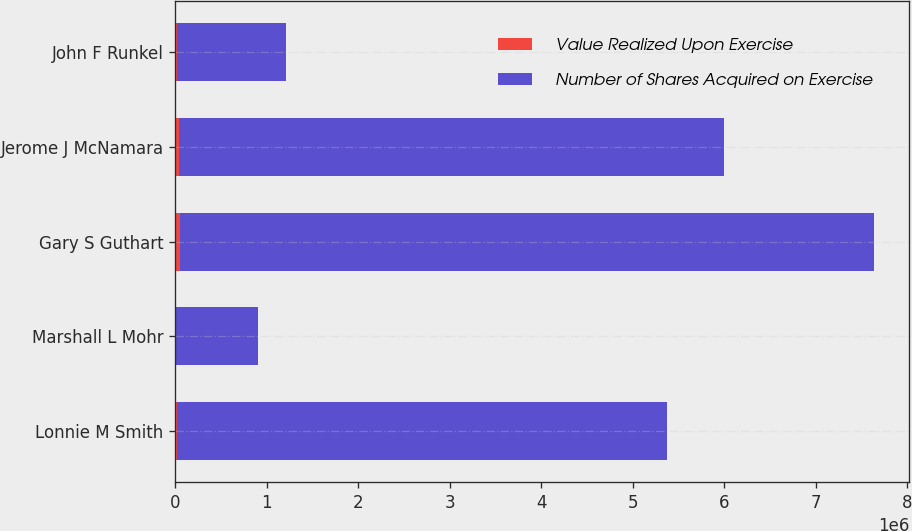Convert chart to OTSL. <chart><loc_0><loc_0><loc_500><loc_500><stacked_bar_chart><ecel><fcel>Lonnie M Smith<fcel>Marshall L Mohr<fcel>Gary S Guthart<fcel>Jerome J McNamara<fcel>John F Runkel<nl><fcel>Value Realized Upon Exercise<fcel>22500<fcel>8000<fcel>55750<fcel>40160<fcel>23459<nl><fcel>Number of Shares Acquired on Exercise<fcel>5.3538e+06<fcel>893040<fcel>7.58412e+06<fcel>5.95794e+06<fcel>1.18325e+06<nl></chart> 